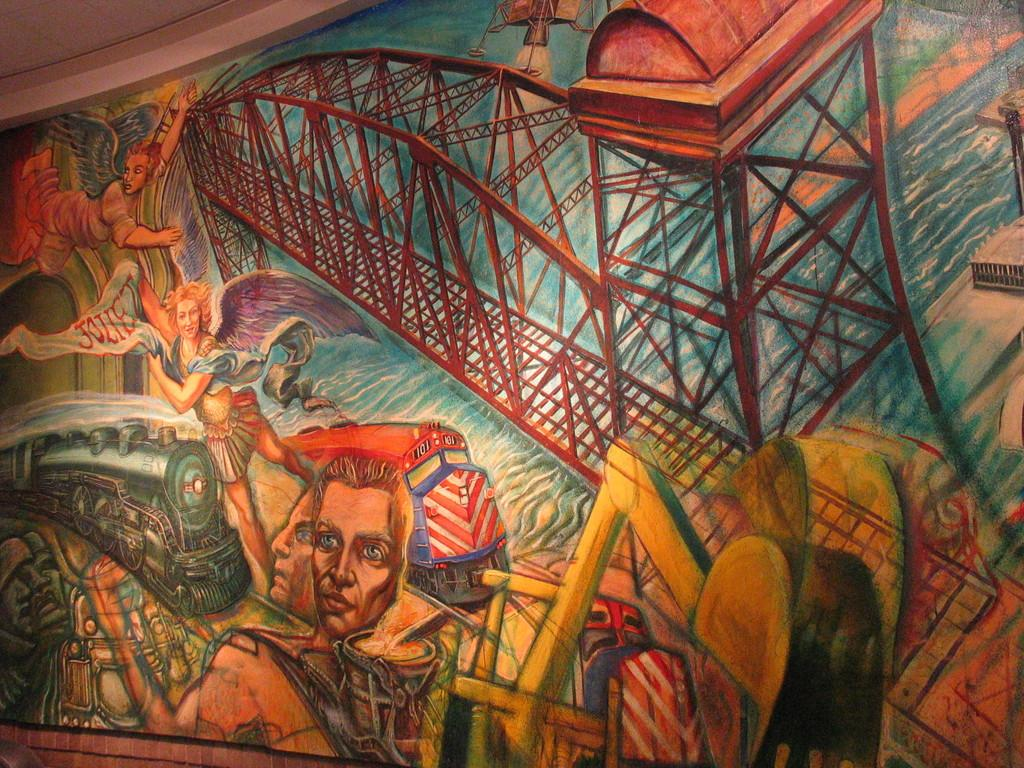What is the main subject of the image? The main subject of the image is a huge painting. What can be seen in the painting? The painting contains a few persons, a train, a bridge, and water. What part of the room is visible in the image? The ceiling is visible at the top of the image. Is there a fight happening between the persons in the painting? There is no indication of a fight in the painting; it only shows a few persons, a train, a bridge, and water. Can you see any cats in the painting? There are no cats present in the painting; it contains only the persons, train, bridge, and water. 